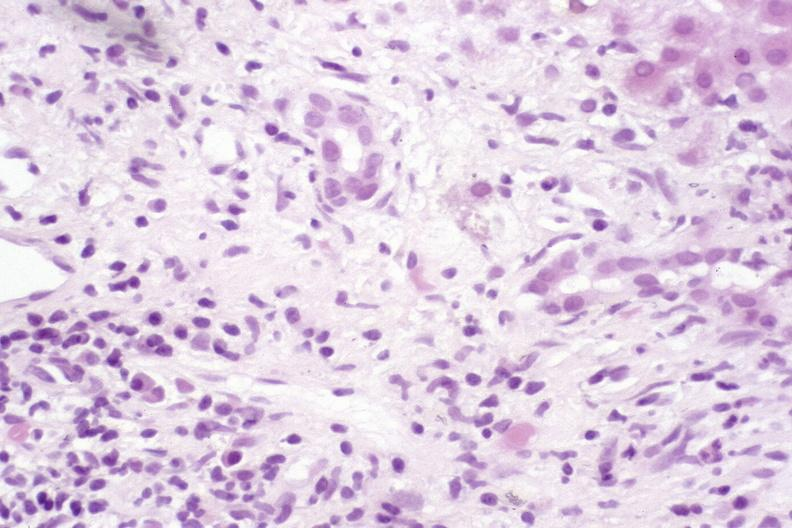what does this image show?
Answer the question using a single word or phrase. Primary sclerosing cholangitis 